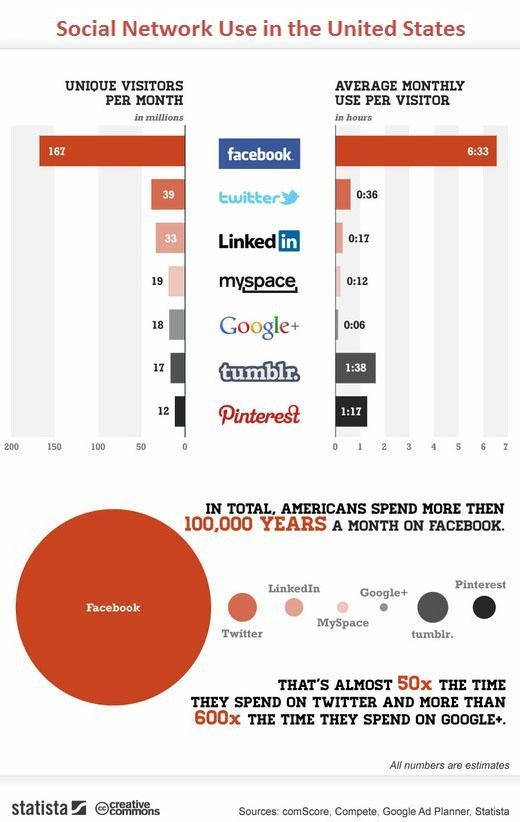What is the background color of facebook logo in the bar chart- red, green, blue, black?
Answer the question with a short phrase. blue Which is the second least used social networking site per month? tumblr. Which is the second most used social networking site per month? twitter Which is the second most used social networking site per visitor in United States? tumblr. How many social networking sites are listed in the info graphic? 7 Which is the second least used social networking site per visitor in United States? myspace 